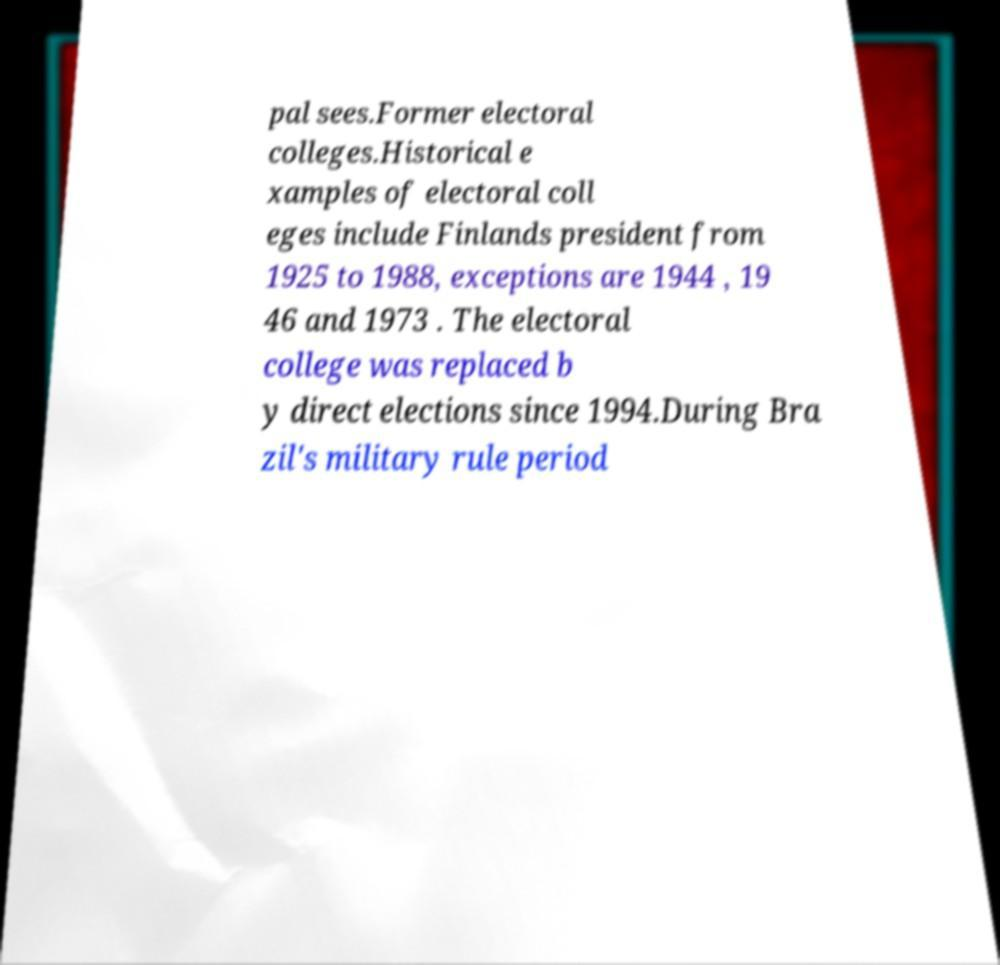For documentation purposes, I need the text within this image transcribed. Could you provide that? pal sees.Former electoral colleges.Historical e xamples of electoral coll eges include Finlands president from 1925 to 1988, exceptions are 1944 , 19 46 and 1973 . The electoral college was replaced b y direct elections since 1994.During Bra zil's military rule period 